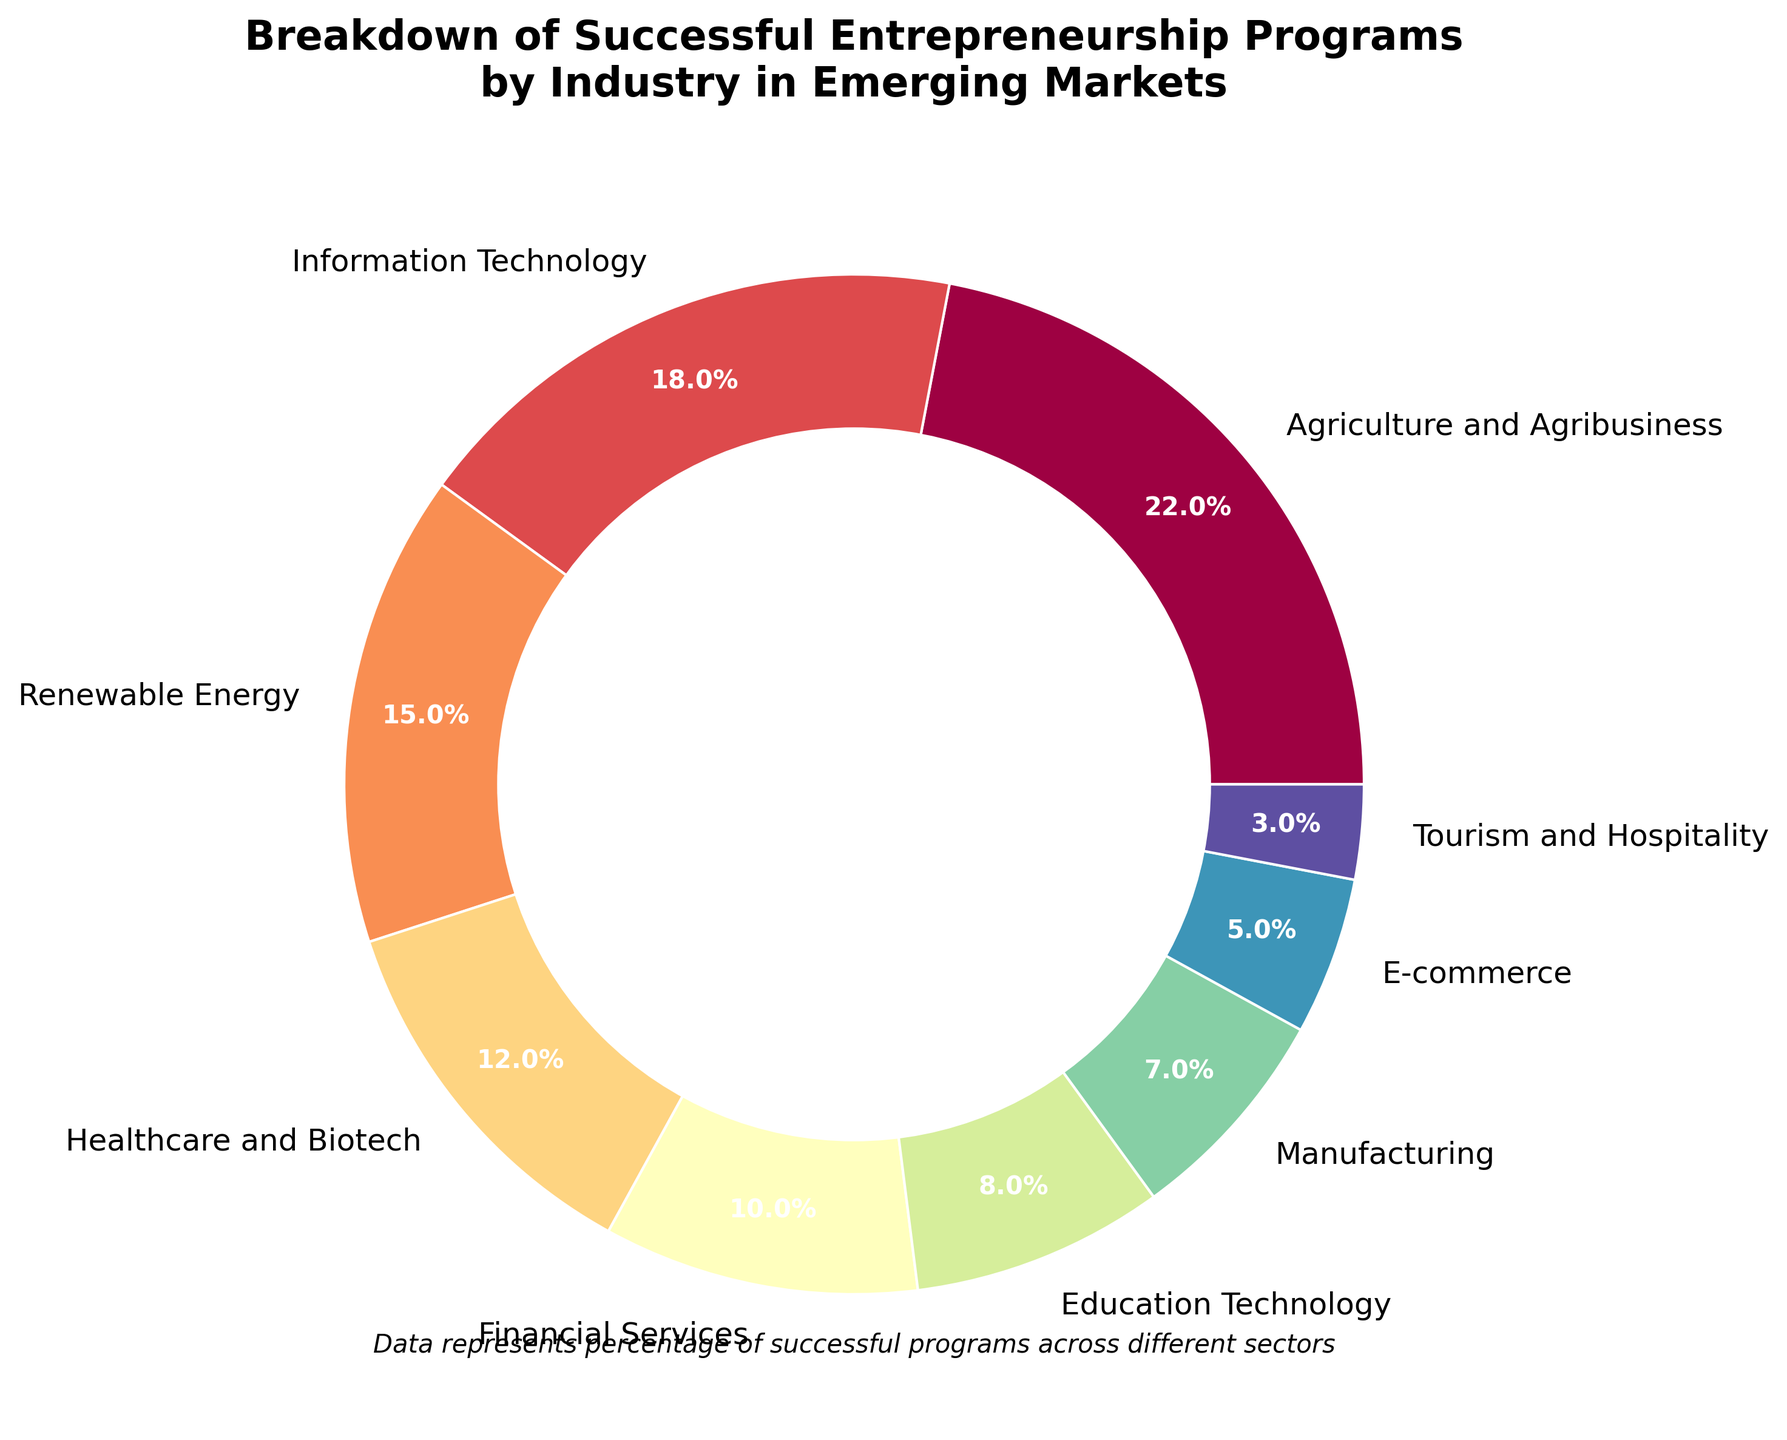Which industry has the highest percentage of successful entrepreneurship programs? The highest percentage section on the pie chart corresponds to the "Agriculture and Agribusiness" sector at 22%.
Answer: Agriculture and Agribusiness How does the percentage of successful entrepreneurship programs in Information Technology compare to that in Healthcare and Biotech? The pie chart shows 18% for Information Technology and 12% for Healthcare and Biotech. Comparing the two, Information Technology has a higher percentage by 6%.
Answer: Information Technology is higher by 6% What is the combined percentage of successful programs in Financial Services and Education Technology? From the pie chart, Financial Services account for 10% and Education Technology for 8%. Summing these two percentages, 10% + 8% = 18%.
Answer: 18% Which industry has the smallest percentage of successful entrepreneurship programs, and what is that percentage? The smallest section on the pie chart is labeled "Tourism and Hospitality," with a percentage of 3%.
Answer: Tourism and Hospitality, 3% What is the difference in percentage between Renewable Energy and Manufacturing? The pie chart lists Renewable Energy at 15% and Manufacturing at 7%. The difference is 15% - 7% = 8%.
Answer: 8% How does the percentage of successful entrepreneurship programs in Agriculture and Agribusiness compare to the total percentage of successful programs in Healthcare and Biotech, E-commerce, and Tourism and Hospitality combined? Agriculture and Agribusiness is at 22%. Healthcare and Biotech (12%) + E-commerce (5%) + Tourism and Hospitality (3%) equals 20%. Thus, Agriculture and Agribusiness has a 2% higher percentage.
Answer: Agriculture and Agribusiness is higher by 2% If you were to combine the percentages of the top three industries, what would be the total percentage? The top three industries by percentage are Agriculture and Agribusiness (22%), Information Technology (18%), and Renewable Energy (15%). Adding these, 22% + 18% + 15% = 55%.
Answer: 55% Which two industries together make up the same percentage as Education Technology? Education Technology is at 8%. The pie chart shows that Manufacturing (7%) and Tourism and Hospitality (3%) together sum to 7% + 3% = 10%, which is close but not identical. However, Tourism and Hospitality (3%) and E-commerce (5%) together make exactly 8%.
Answer: Tourism and Hospitality and E-commerce What is the total percentage of industries with less than 10% of successful entrepreneurship programs? The industries with less than 10% are Manufacturing (7%), E-commerce (5%), and Tourism and Hospitality (3%). Summing these, 7% + 5% + 3% = 15%.
Answer: 15% 